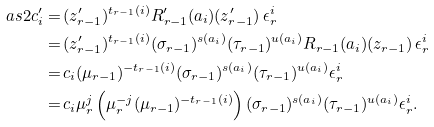<formula> <loc_0><loc_0><loc_500><loc_500>\ a s { 2 } c ^ { \prime } _ { i } = & \, ( z ^ { \prime } _ { r - 1 } ) ^ { t _ { r - 1 } ( i ) } R ^ { \prime } _ { r - 1 } ( a _ { i } ) ( z ^ { \prime } _ { r - 1 } ) \, \epsilon _ { r } ^ { i } \\ = & \, ( z ^ { \prime } _ { r - 1 } ) ^ { t _ { r - 1 } ( i ) } ( \sigma _ { r - 1 } ) ^ { s ( a _ { i } ) } ( \tau _ { r - 1 } ) ^ { u ( a _ { i } ) } R _ { r - 1 } ( a _ { i } ) ( z _ { r - 1 } ) \, \epsilon _ { r } ^ { i } \\ = & \, c _ { i } ( \mu _ { r - 1 } ) ^ { - t _ { r - 1 } ( i ) } ( \sigma _ { r - 1 } ) ^ { s ( a _ { i } ) } ( \tau _ { r - 1 } ) ^ { u ( a _ { i } ) } \epsilon _ { r } ^ { i } \\ = & \, c _ { i } \mu _ { r } ^ { j } \left ( \mu _ { r } ^ { - j } ( \mu _ { r - 1 } ) ^ { - t _ { r - 1 } ( i ) } \right ) ( \sigma _ { r - 1 } ) ^ { s ( a _ { i } ) } ( \tau _ { r - 1 } ) ^ { u ( a _ { i } ) } \epsilon _ { r } ^ { i } .</formula> 